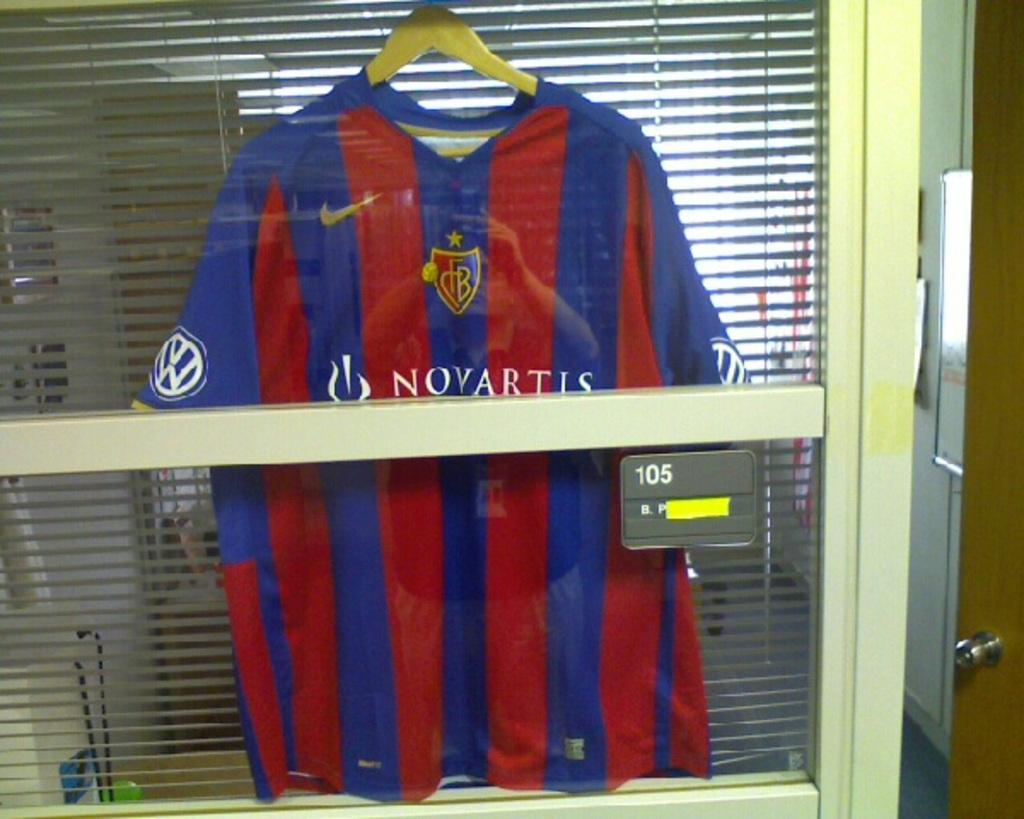What is hanging on the hanger in the image? There is a jersey hanging on a hanger in the image. What is in front of the jersey? There is a wooden stick in front of the jersey. What can be seen in the background of the image? There is a curtain in the background of the image. What is located on the right side of the image? There is a door on the right side of the image. What type of flower is being used as a decoration on the jersey in the image? There are no flowers present on the jersey in the image. What activity is taking place in the image? The image does not depict any specific activity; it shows a jersey hanging on a hanger with a wooden stick in front of it. 